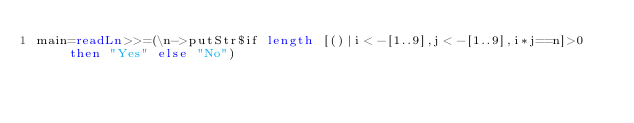Convert code to text. <code><loc_0><loc_0><loc_500><loc_500><_Haskell_>main=readLn>>=(\n->putStr$if length [()|i<-[1..9],j<-[1..9],i*j==n]>0 then "Yes" else "No")</code> 